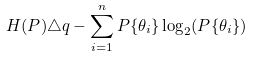Convert formula to latex. <formula><loc_0><loc_0><loc_500><loc_500>H ( P ) \triangle q - \sum _ { i = 1 } ^ { n } P \{ \theta _ { i } \} \log _ { 2 } ( P \{ \theta _ { i } \} )</formula> 